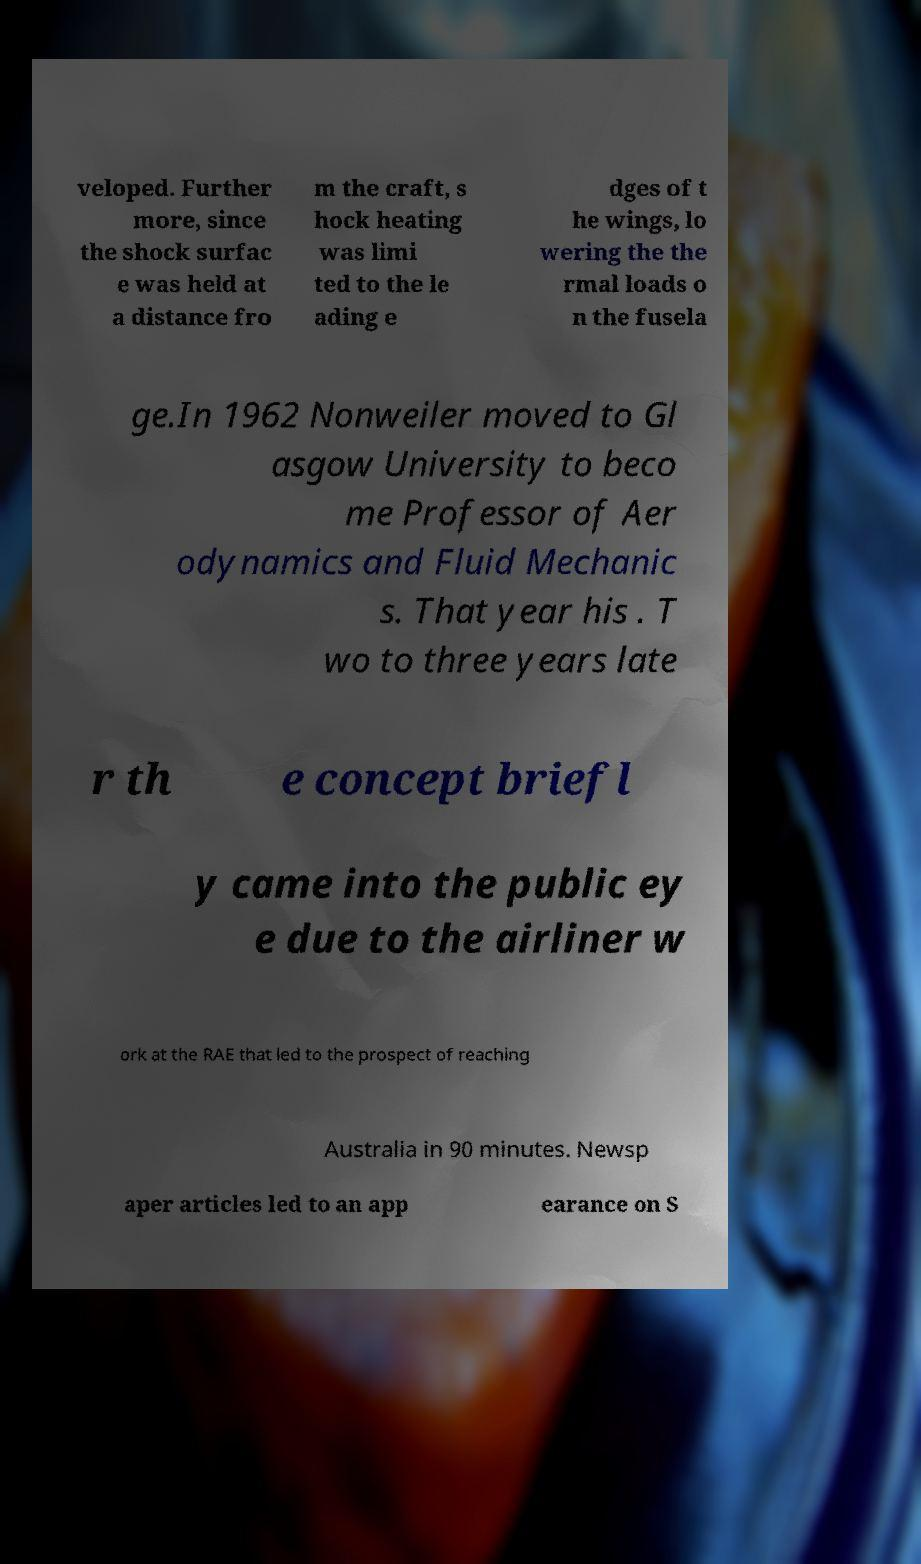Please read and relay the text visible in this image. What does it say? veloped. Further more, since the shock surfac e was held at a distance fro m the craft, s hock heating was limi ted to the le ading e dges of t he wings, lo wering the the rmal loads o n the fusela ge.In 1962 Nonweiler moved to Gl asgow University to beco me Professor of Aer odynamics and Fluid Mechanic s. That year his . T wo to three years late r th e concept briefl y came into the public ey e due to the airliner w ork at the RAE that led to the prospect of reaching Australia in 90 minutes. Newsp aper articles led to an app earance on S 